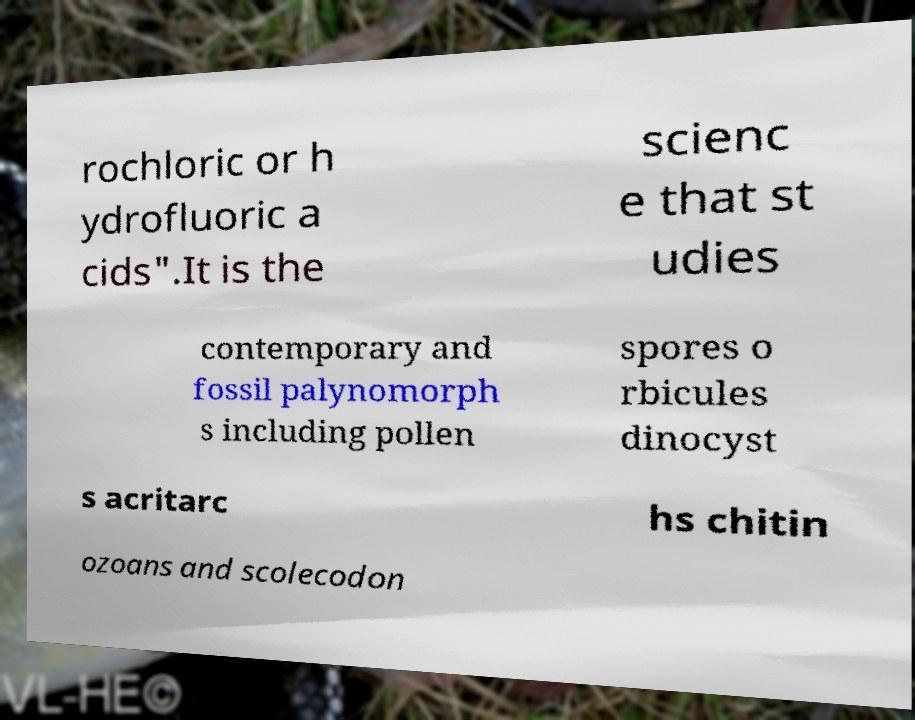Can you accurately transcribe the text from the provided image for me? rochloric or h ydrofluoric a cids".It is the scienc e that st udies contemporary and fossil palynomorph s including pollen spores o rbicules dinocyst s acritarc hs chitin ozoans and scolecodon 